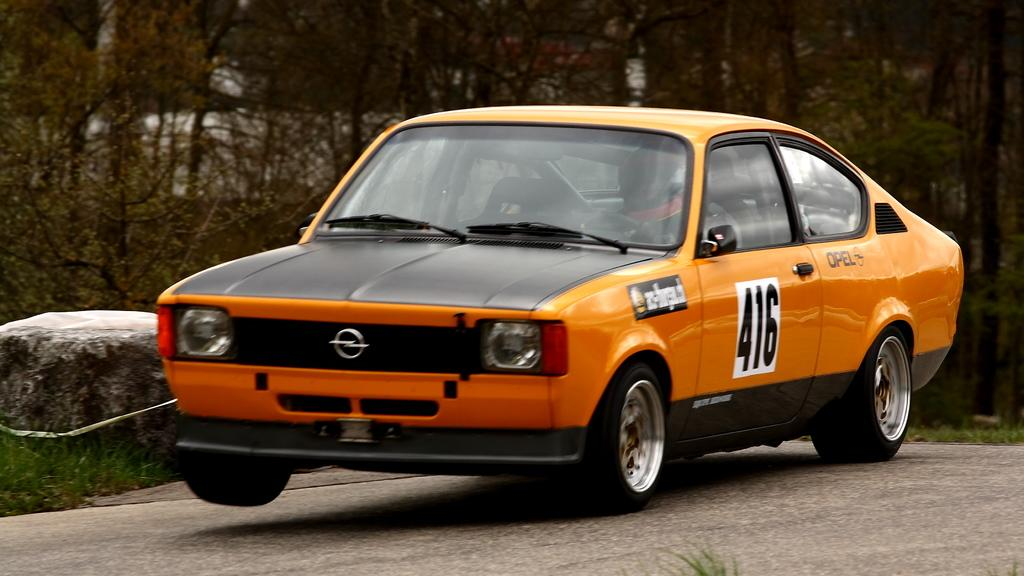What type of vehicle is on the road in the image? There is a car on the road in the image. What natural elements can be seen in the image? Grass and trees are visible in the image. What is the rock in the image used for? The purpose of the rock in the image is not specified, but it could be a natural feature or a decorative element. What riddle is the duck trying to solve in the image? There is no duck present in the image, and therefore no riddle can be observed. What sound do the bells make in the image? There are no bells present in the image, so no sound can be heard. 